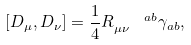<formula> <loc_0><loc_0><loc_500><loc_500>\left [ D _ { \mu } , D _ { \nu } \right ] = \frac { 1 } { 4 } R _ { \mu \nu } ^ { \quad a b } \gamma _ { a b } ,</formula> 